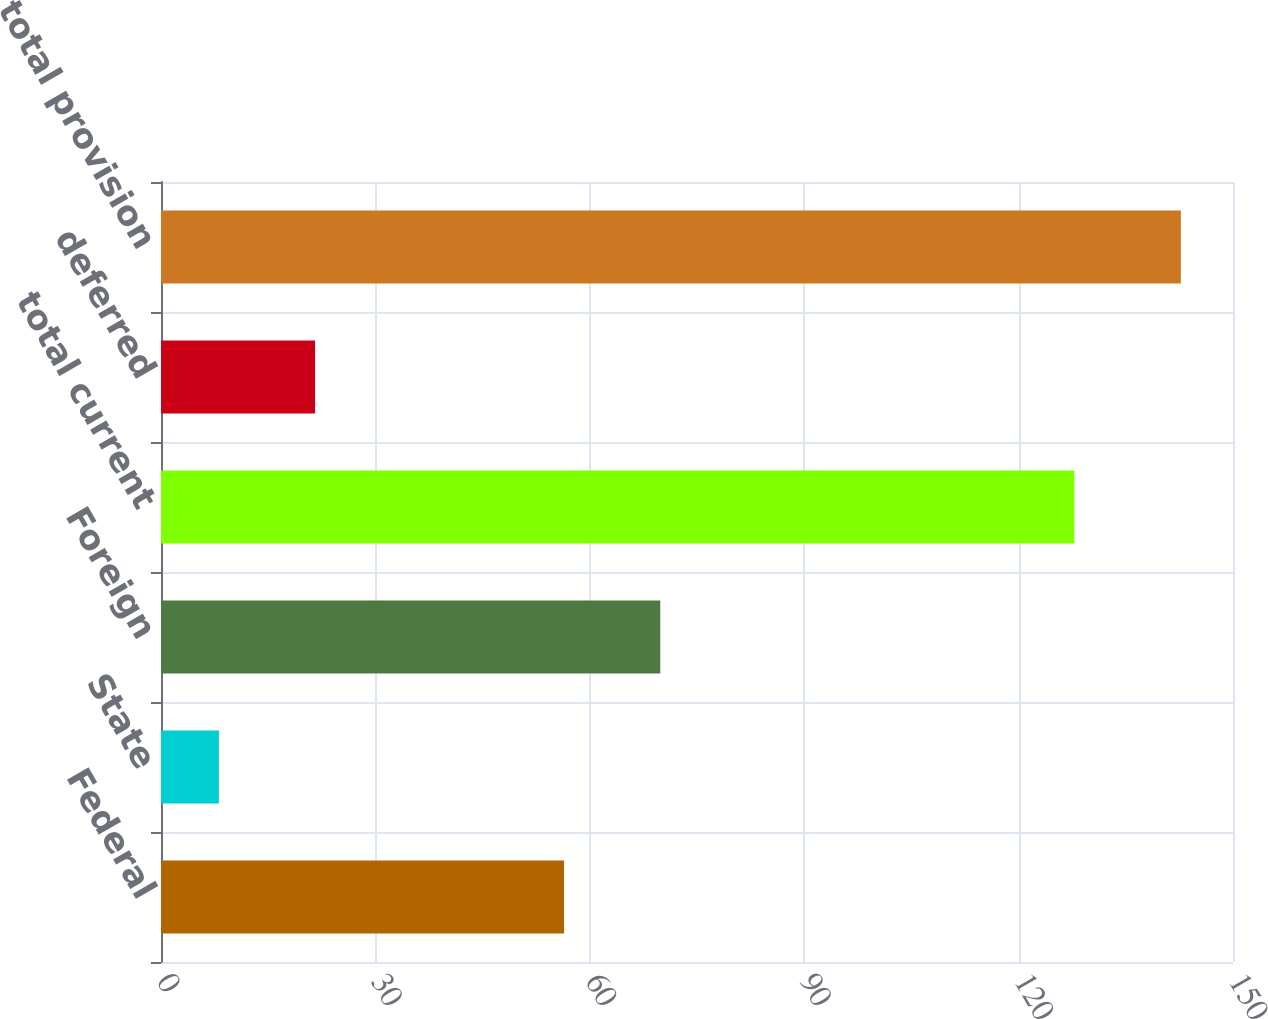<chart> <loc_0><loc_0><loc_500><loc_500><bar_chart><fcel>Federal<fcel>State<fcel>Foreign<fcel>total current<fcel>deferred<fcel>total provision<nl><fcel>56.4<fcel>8.1<fcel>69.86<fcel>127.8<fcel>21.56<fcel>142.7<nl></chart> 